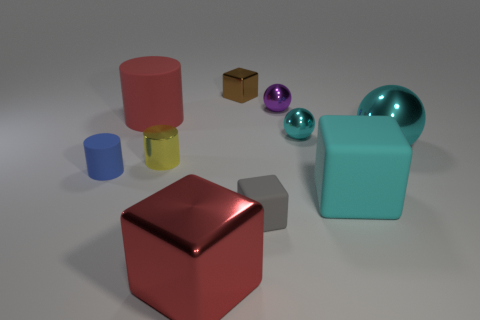Is the tiny cyan object the same shape as the big red rubber thing?
Offer a very short reply. No. How many other objects are the same material as the big ball?
Offer a very short reply. 5. How many small metal objects are the same shape as the large cyan metal thing?
Give a very brief answer. 2. What color is the big thing that is both on the left side of the tiny cyan metallic object and in front of the tiny cyan sphere?
Provide a succinct answer. Red. How many purple spheres are there?
Your answer should be very brief. 1. Is the size of the purple ball the same as the blue thing?
Your answer should be compact. Yes. Is there another small cube of the same color as the tiny metallic block?
Give a very brief answer. No. There is a big rubber thing that is behind the small cyan metal sphere; does it have the same shape as the tiny yellow metallic thing?
Offer a terse response. Yes. How many shiny things have the same size as the cyan matte block?
Provide a succinct answer. 2. There is a tiny cylinder in front of the tiny yellow metallic thing; how many tiny cyan metal spheres are in front of it?
Make the answer very short. 0. 